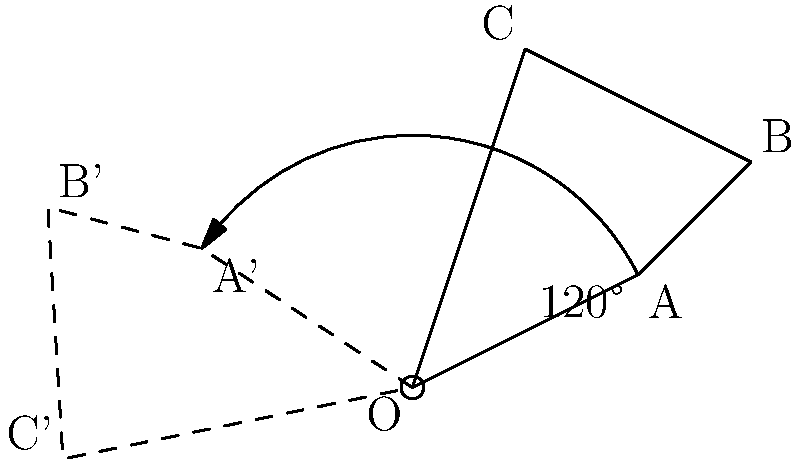In a study of bacterial cell morphology, you are analyzing a 2D model of a rod-shaped bacterium involved in anaerobic digestion. The cell is represented by the triangle ABC with vertices A(2,1), B(3,2), and C(1,3). If you rotate this model 120° counterclockwise around the origin O(0,0), what are the coordinates of point A after rotation? To find the coordinates of point A after a 120° counterclockwise rotation around the origin, we can follow these steps:

1) The rotation matrix for a counterclockwise rotation by angle $\theta$ is:

   $$R(\theta) = \begin{pmatrix} \cos\theta & -\sin\theta \\ \sin\theta & \cos\theta \end{pmatrix}$$

2) For a 120° rotation, $\theta = 120° = \frac{2\pi}{3}$ radians. We can calculate:

   $\cos(120°) = -\frac{1}{2}$
   $\sin(120°) = \frac{\sqrt{3}}{2}$

3) Substituting these values into the rotation matrix:

   $$R(120°) = \begin{pmatrix} -\frac{1}{2} & -\frac{\sqrt{3}}{2} \\ \frac{\sqrt{3}}{2} & -\frac{1}{2} \end{pmatrix}$$

4) To rotate point A(2,1), we multiply this matrix by the column vector $\begin{pmatrix} 2 \\ 1 \end{pmatrix}$:

   $$\begin{pmatrix} -\frac{1}{2} & -\frac{\sqrt{3}}{2} \\ \frac{\sqrt{3}}{2} & -\frac{1}{2} \end{pmatrix} \begin{pmatrix} 2 \\ 1 \end{pmatrix} = \begin{pmatrix} -1-\frac{\sqrt{3}}{2} \\ \sqrt{3}-\frac{1}{2} \end{pmatrix}$$

5) Simplifying:

   $$A' = (-1-\frac{\sqrt{3}}{2}, \sqrt{3}-\frac{1}{2})$$

Therefore, after rotation, point A moves to coordinates $(-1-\frac{\sqrt{3}}{2}, \sqrt{3}-\frac{1}{2})$.
Answer: $(-1-\frac{\sqrt{3}}{2}, \sqrt{3}-\frac{1}{2})$ 